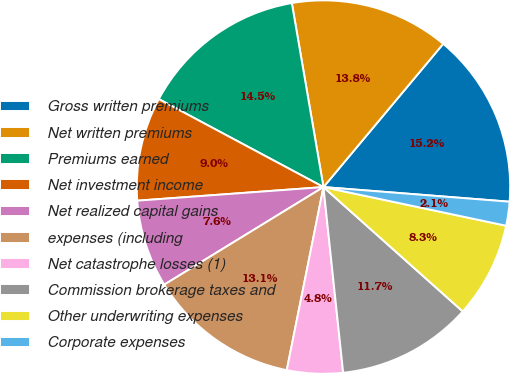<chart> <loc_0><loc_0><loc_500><loc_500><pie_chart><fcel>Gross written premiums<fcel>Net written premiums<fcel>Premiums earned<fcel>Net investment income<fcel>Net realized capital gains<fcel>expenses (including<fcel>Net catastrophe losses (1)<fcel>Commission brokerage taxes and<fcel>Other underwriting expenses<fcel>Corporate expenses<nl><fcel>15.17%<fcel>13.79%<fcel>14.48%<fcel>8.97%<fcel>7.59%<fcel>13.1%<fcel>4.83%<fcel>11.72%<fcel>8.28%<fcel>2.07%<nl></chart> 